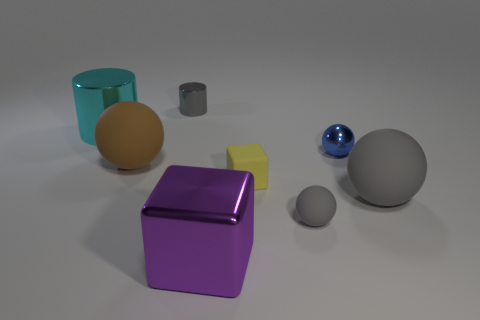Subtract all small shiny balls. How many balls are left? 3 Add 1 brown metallic objects. How many objects exist? 9 Subtract all gray cubes. How many gray cylinders are left? 1 Subtract all small blocks. Subtract all cyan balls. How many objects are left? 7 Add 2 shiny cubes. How many shiny cubes are left? 3 Add 5 big gray things. How many big gray things exist? 6 Subtract all gray spheres. How many spheres are left? 2 Subtract 0 brown cylinders. How many objects are left? 8 Subtract all cylinders. How many objects are left? 6 Subtract 2 balls. How many balls are left? 2 